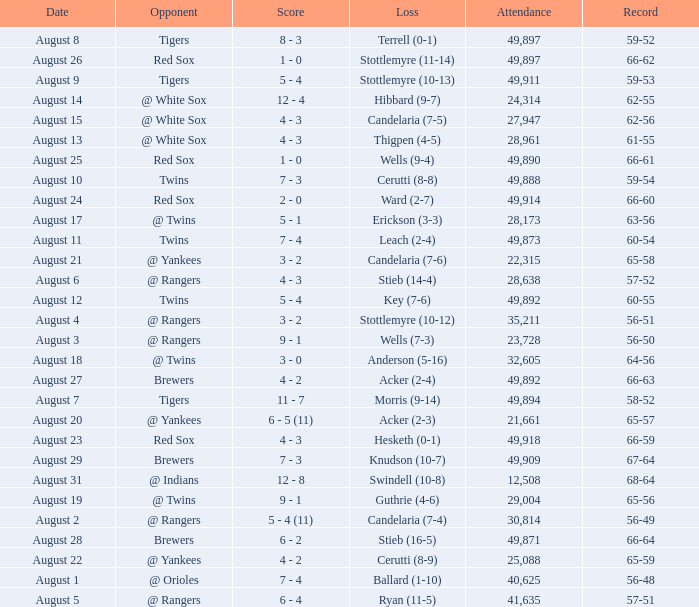What was the Attendance high on August 28? 49871.0. 